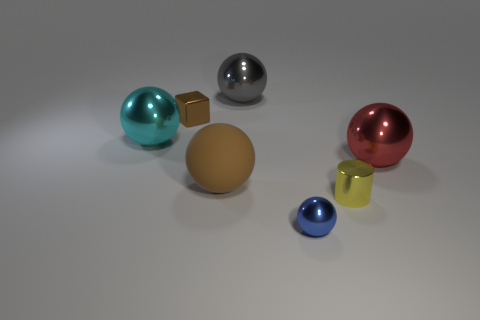There is a small cylinder that is the same material as the blue thing; what color is it?
Keep it short and to the point. Yellow. Are there fewer tiny yellow shiny cylinders that are in front of the matte object than cyan spheres that are to the right of the block?
Provide a succinct answer. No. Is the color of the small shiny object that is behind the yellow shiny cylinder the same as the big thing in front of the large red metal ball?
Your response must be concise. Yes. Is there a tiny blue sphere made of the same material as the large brown ball?
Ensure brevity in your answer.  No. How big is the brown thing behind the ball that is on the right side of the tiny shiny cylinder?
Provide a succinct answer. Small. Is the number of cyan shiny things greater than the number of small brown rubber cylinders?
Make the answer very short. Yes. Is the size of the shiny ball left of the gray object the same as the gray object?
Keep it short and to the point. Yes. How many tiny objects have the same color as the small ball?
Your answer should be very brief. 0. Is the shape of the yellow metal thing the same as the blue thing?
Provide a succinct answer. No. Is there anything else that is the same size as the brown matte sphere?
Offer a very short reply. Yes. 